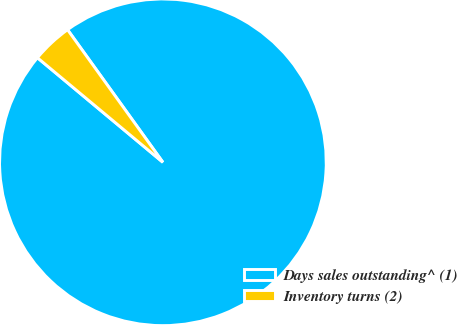Convert chart. <chart><loc_0><loc_0><loc_500><loc_500><pie_chart><fcel>Days sales outstanding^ (1)<fcel>Inventory turns (2)<nl><fcel>95.98%<fcel>4.02%<nl></chart> 